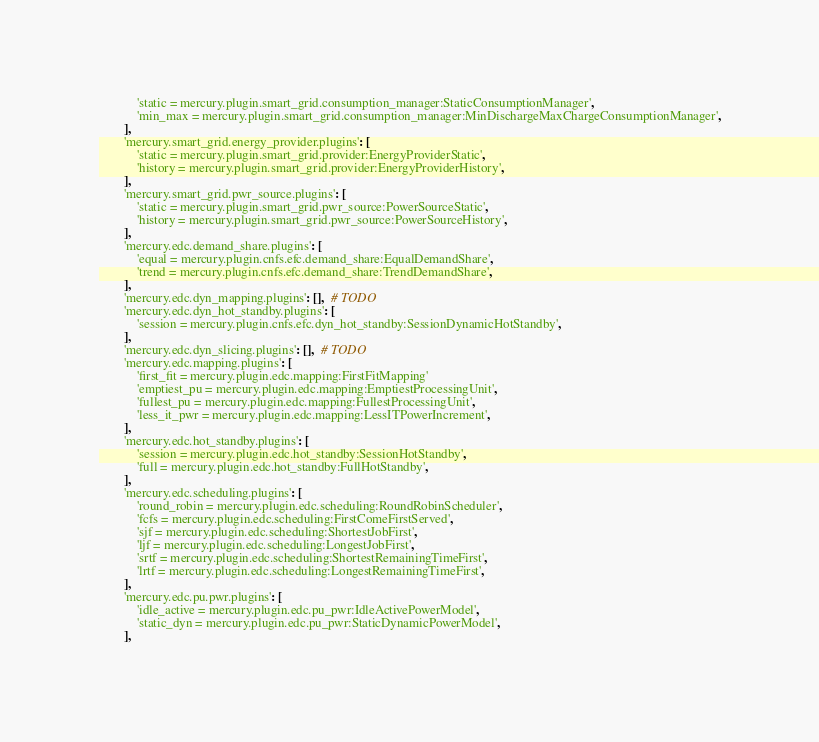Convert code to text. <code><loc_0><loc_0><loc_500><loc_500><_Python_>            'static = mercury.plugin.smart_grid.consumption_manager:StaticConsumptionManager',
            'min_max = mercury.plugin.smart_grid.consumption_manager:MinDischargeMaxChargeConsumptionManager',
        ],
        'mercury.smart_grid.energy_provider.plugins': [
            'static = mercury.plugin.smart_grid.provider:EnergyProviderStatic',
            'history = mercury.plugin.smart_grid.provider:EnergyProviderHistory',
        ],
        'mercury.smart_grid.pwr_source.plugins': [
            'static = mercury.plugin.smart_grid.pwr_source:PowerSourceStatic',
            'history = mercury.plugin.smart_grid.pwr_source:PowerSourceHistory',
        ],
        'mercury.edc.demand_share.plugins': [
            'equal = mercury.plugin.cnfs.efc.demand_share:EqualDemandShare',
            'trend = mercury.plugin.cnfs.efc.demand_share:TrendDemandShare',
        ],
        'mercury.edc.dyn_mapping.plugins': [],  # TODO
        'mercury.edc.dyn_hot_standby.plugins': [
            'session = mercury.plugin.cnfs.efc.dyn_hot_standby:SessionDynamicHotStandby',
        ],
        'mercury.edc.dyn_slicing.plugins': [],  # TODO
        'mercury.edc.mapping.plugins': [
            'first_fit = mercury.plugin.edc.mapping:FirstFitMapping'
            'emptiest_pu = mercury.plugin.edc.mapping:EmptiestProcessingUnit',
            'fullest_pu = mercury.plugin.edc.mapping:FullestProcessingUnit',
            'less_it_pwr = mercury.plugin.edc.mapping:LessITPowerIncrement',
        ],
        'mercury.edc.hot_standby.plugins': [
            'session = mercury.plugin.edc.hot_standby:SessionHotStandby',
            'full = mercury.plugin.edc.hot_standby:FullHotStandby',
        ],
        'mercury.edc.scheduling.plugins': [
            'round_robin = mercury.plugin.edc.scheduling:RoundRobinScheduler',
            'fcfs = mercury.plugin.edc.scheduling:FirstComeFirstServed',
            'sjf = mercury.plugin.edc.scheduling:ShortestJobFirst',
            'ljf = mercury.plugin.edc.scheduling:LongestJobFirst',
            'srtf = mercury.plugin.edc.scheduling:ShortestRemainingTimeFirst',
            'lrtf = mercury.plugin.edc.scheduling:LongestRemainingTimeFirst',
        ],
        'mercury.edc.pu.pwr.plugins': [
            'idle_active = mercury.plugin.edc.pu_pwr:IdleActivePowerModel',
            'static_dyn = mercury.plugin.edc.pu_pwr:StaticDynamicPowerModel',
        ],</code> 